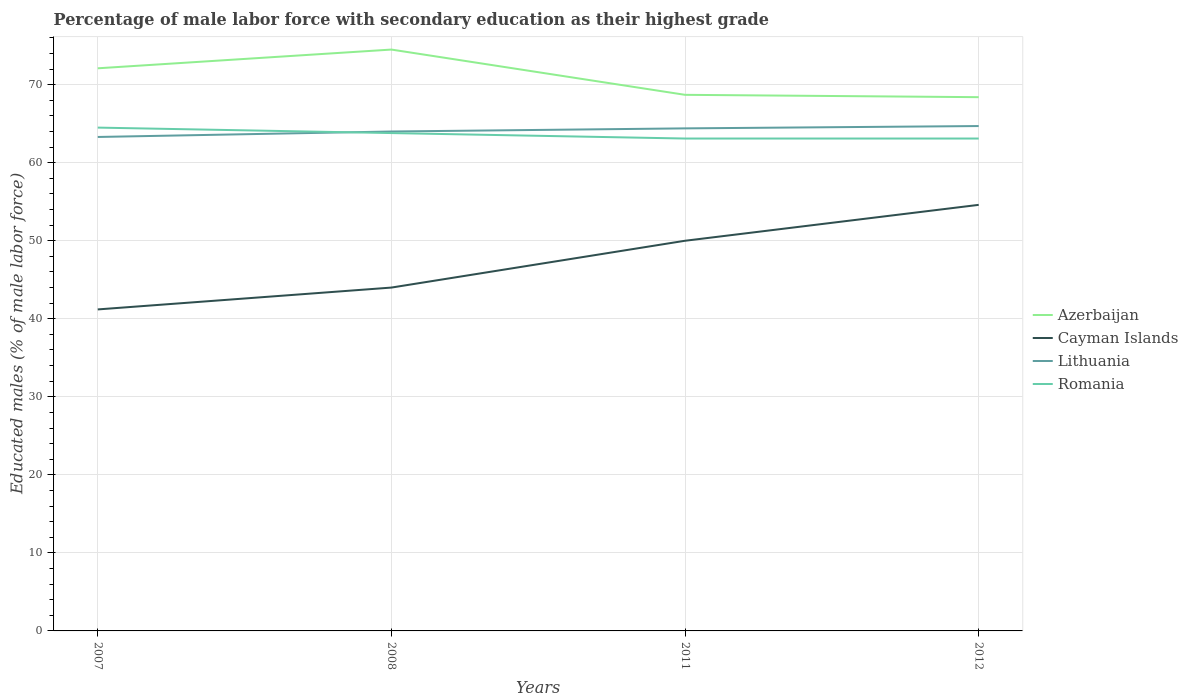How many different coloured lines are there?
Offer a very short reply. 4. Does the line corresponding to Romania intersect with the line corresponding to Azerbaijan?
Your answer should be compact. No. Across all years, what is the maximum percentage of male labor force with secondary education in Lithuania?
Your answer should be compact. 63.3. What is the total percentage of male labor force with secondary education in Lithuania in the graph?
Your response must be concise. -1.1. What is the difference between the highest and the second highest percentage of male labor force with secondary education in Romania?
Your answer should be compact. 1.4. What is the difference between the highest and the lowest percentage of male labor force with secondary education in Lithuania?
Keep it short and to the point. 2. Is the percentage of male labor force with secondary education in Cayman Islands strictly greater than the percentage of male labor force with secondary education in Azerbaijan over the years?
Offer a terse response. Yes. How many years are there in the graph?
Provide a succinct answer. 4. What is the difference between two consecutive major ticks on the Y-axis?
Your response must be concise. 10. Are the values on the major ticks of Y-axis written in scientific E-notation?
Provide a short and direct response. No. Where does the legend appear in the graph?
Offer a very short reply. Center right. How many legend labels are there?
Your response must be concise. 4. How are the legend labels stacked?
Give a very brief answer. Vertical. What is the title of the graph?
Your response must be concise. Percentage of male labor force with secondary education as their highest grade. What is the label or title of the Y-axis?
Keep it short and to the point. Educated males (% of male labor force). What is the Educated males (% of male labor force) of Azerbaijan in 2007?
Ensure brevity in your answer.  72.1. What is the Educated males (% of male labor force) of Cayman Islands in 2007?
Your response must be concise. 41.2. What is the Educated males (% of male labor force) in Lithuania in 2007?
Make the answer very short. 63.3. What is the Educated males (% of male labor force) in Romania in 2007?
Your answer should be very brief. 64.5. What is the Educated males (% of male labor force) in Azerbaijan in 2008?
Provide a succinct answer. 74.5. What is the Educated males (% of male labor force) in Cayman Islands in 2008?
Your answer should be very brief. 44. What is the Educated males (% of male labor force) of Romania in 2008?
Your answer should be compact. 63.8. What is the Educated males (% of male labor force) in Azerbaijan in 2011?
Give a very brief answer. 68.7. What is the Educated males (% of male labor force) of Lithuania in 2011?
Provide a succinct answer. 64.4. What is the Educated males (% of male labor force) of Romania in 2011?
Ensure brevity in your answer.  63.1. What is the Educated males (% of male labor force) of Azerbaijan in 2012?
Ensure brevity in your answer.  68.4. What is the Educated males (% of male labor force) of Cayman Islands in 2012?
Offer a very short reply. 54.6. What is the Educated males (% of male labor force) of Lithuania in 2012?
Make the answer very short. 64.7. What is the Educated males (% of male labor force) in Romania in 2012?
Offer a terse response. 63.1. Across all years, what is the maximum Educated males (% of male labor force) of Azerbaijan?
Your answer should be compact. 74.5. Across all years, what is the maximum Educated males (% of male labor force) in Cayman Islands?
Provide a short and direct response. 54.6. Across all years, what is the maximum Educated males (% of male labor force) in Lithuania?
Keep it short and to the point. 64.7. Across all years, what is the maximum Educated males (% of male labor force) of Romania?
Provide a succinct answer. 64.5. Across all years, what is the minimum Educated males (% of male labor force) in Azerbaijan?
Provide a short and direct response. 68.4. Across all years, what is the minimum Educated males (% of male labor force) of Cayman Islands?
Offer a very short reply. 41.2. Across all years, what is the minimum Educated males (% of male labor force) in Lithuania?
Give a very brief answer. 63.3. Across all years, what is the minimum Educated males (% of male labor force) of Romania?
Ensure brevity in your answer.  63.1. What is the total Educated males (% of male labor force) of Azerbaijan in the graph?
Your answer should be very brief. 283.7. What is the total Educated males (% of male labor force) in Cayman Islands in the graph?
Ensure brevity in your answer.  189.8. What is the total Educated males (% of male labor force) in Lithuania in the graph?
Your answer should be very brief. 256.4. What is the total Educated males (% of male labor force) in Romania in the graph?
Make the answer very short. 254.5. What is the difference between the Educated males (% of male labor force) in Azerbaijan in 2007 and that in 2008?
Ensure brevity in your answer.  -2.4. What is the difference between the Educated males (% of male labor force) of Cayman Islands in 2007 and that in 2008?
Offer a very short reply. -2.8. What is the difference between the Educated males (% of male labor force) in Lithuania in 2007 and that in 2011?
Your answer should be very brief. -1.1. What is the difference between the Educated males (% of male labor force) in Romania in 2007 and that in 2011?
Ensure brevity in your answer.  1.4. What is the difference between the Educated males (% of male labor force) of Romania in 2007 and that in 2012?
Your answer should be compact. 1.4. What is the difference between the Educated males (% of male labor force) in Cayman Islands in 2008 and that in 2011?
Offer a very short reply. -6. What is the difference between the Educated males (% of male labor force) in Lithuania in 2008 and that in 2011?
Offer a very short reply. -0.4. What is the difference between the Educated males (% of male labor force) in Azerbaijan in 2008 and that in 2012?
Your answer should be compact. 6.1. What is the difference between the Educated males (% of male labor force) in Cayman Islands in 2008 and that in 2012?
Ensure brevity in your answer.  -10.6. What is the difference between the Educated males (% of male labor force) in Romania in 2008 and that in 2012?
Provide a short and direct response. 0.7. What is the difference between the Educated males (% of male labor force) in Azerbaijan in 2011 and that in 2012?
Ensure brevity in your answer.  0.3. What is the difference between the Educated males (% of male labor force) in Romania in 2011 and that in 2012?
Offer a terse response. 0. What is the difference between the Educated males (% of male labor force) in Azerbaijan in 2007 and the Educated males (% of male labor force) in Cayman Islands in 2008?
Keep it short and to the point. 28.1. What is the difference between the Educated males (% of male labor force) of Azerbaijan in 2007 and the Educated males (% of male labor force) of Romania in 2008?
Keep it short and to the point. 8.3. What is the difference between the Educated males (% of male labor force) in Cayman Islands in 2007 and the Educated males (% of male labor force) in Lithuania in 2008?
Give a very brief answer. -22.8. What is the difference between the Educated males (% of male labor force) of Cayman Islands in 2007 and the Educated males (% of male labor force) of Romania in 2008?
Your answer should be compact. -22.6. What is the difference between the Educated males (% of male labor force) of Azerbaijan in 2007 and the Educated males (% of male labor force) of Cayman Islands in 2011?
Your response must be concise. 22.1. What is the difference between the Educated males (% of male labor force) of Cayman Islands in 2007 and the Educated males (% of male labor force) of Lithuania in 2011?
Ensure brevity in your answer.  -23.2. What is the difference between the Educated males (% of male labor force) in Cayman Islands in 2007 and the Educated males (% of male labor force) in Romania in 2011?
Provide a succinct answer. -21.9. What is the difference between the Educated males (% of male labor force) in Lithuania in 2007 and the Educated males (% of male labor force) in Romania in 2011?
Your answer should be compact. 0.2. What is the difference between the Educated males (% of male labor force) of Azerbaijan in 2007 and the Educated males (% of male labor force) of Cayman Islands in 2012?
Your answer should be very brief. 17.5. What is the difference between the Educated males (% of male labor force) in Azerbaijan in 2007 and the Educated males (% of male labor force) in Romania in 2012?
Your answer should be compact. 9. What is the difference between the Educated males (% of male labor force) of Cayman Islands in 2007 and the Educated males (% of male labor force) of Lithuania in 2012?
Offer a very short reply. -23.5. What is the difference between the Educated males (% of male labor force) of Cayman Islands in 2007 and the Educated males (% of male labor force) of Romania in 2012?
Your response must be concise. -21.9. What is the difference between the Educated males (% of male labor force) in Azerbaijan in 2008 and the Educated males (% of male labor force) in Cayman Islands in 2011?
Ensure brevity in your answer.  24.5. What is the difference between the Educated males (% of male labor force) of Cayman Islands in 2008 and the Educated males (% of male labor force) of Lithuania in 2011?
Provide a short and direct response. -20.4. What is the difference between the Educated males (% of male labor force) in Cayman Islands in 2008 and the Educated males (% of male labor force) in Romania in 2011?
Provide a succinct answer. -19.1. What is the difference between the Educated males (% of male labor force) in Azerbaijan in 2008 and the Educated males (% of male labor force) in Cayman Islands in 2012?
Provide a short and direct response. 19.9. What is the difference between the Educated males (% of male labor force) in Azerbaijan in 2008 and the Educated males (% of male labor force) in Romania in 2012?
Ensure brevity in your answer.  11.4. What is the difference between the Educated males (% of male labor force) in Cayman Islands in 2008 and the Educated males (% of male labor force) in Lithuania in 2012?
Give a very brief answer. -20.7. What is the difference between the Educated males (% of male labor force) in Cayman Islands in 2008 and the Educated males (% of male labor force) in Romania in 2012?
Give a very brief answer. -19.1. What is the difference between the Educated males (% of male labor force) of Lithuania in 2008 and the Educated males (% of male labor force) of Romania in 2012?
Provide a short and direct response. 0.9. What is the difference between the Educated males (% of male labor force) of Azerbaijan in 2011 and the Educated males (% of male labor force) of Lithuania in 2012?
Ensure brevity in your answer.  4. What is the difference between the Educated males (% of male labor force) of Azerbaijan in 2011 and the Educated males (% of male labor force) of Romania in 2012?
Ensure brevity in your answer.  5.6. What is the difference between the Educated males (% of male labor force) of Cayman Islands in 2011 and the Educated males (% of male labor force) of Lithuania in 2012?
Offer a very short reply. -14.7. What is the difference between the Educated males (% of male labor force) in Cayman Islands in 2011 and the Educated males (% of male labor force) in Romania in 2012?
Your response must be concise. -13.1. What is the average Educated males (% of male labor force) in Azerbaijan per year?
Your answer should be compact. 70.92. What is the average Educated males (% of male labor force) of Cayman Islands per year?
Make the answer very short. 47.45. What is the average Educated males (% of male labor force) of Lithuania per year?
Your answer should be compact. 64.1. What is the average Educated males (% of male labor force) of Romania per year?
Provide a succinct answer. 63.62. In the year 2007, what is the difference between the Educated males (% of male labor force) in Azerbaijan and Educated males (% of male labor force) in Cayman Islands?
Provide a succinct answer. 30.9. In the year 2007, what is the difference between the Educated males (% of male labor force) of Azerbaijan and Educated males (% of male labor force) of Romania?
Provide a short and direct response. 7.6. In the year 2007, what is the difference between the Educated males (% of male labor force) of Cayman Islands and Educated males (% of male labor force) of Lithuania?
Offer a very short reply. -22.1. In the year 2007, what is the difference between the Educated males (% of male labor force) of Cayman Islands and Educated males (% of male labor force) of Romania?
Offer a terse response. -23.3. In the year 2007, what is the difference between the Educated males (% of male labor force) in Lithuania and Educated males (% of male labor force) in Romania?
Offer a very short reply. -1.2. In the year 2008, what is the difference between the Educated males (% of male labor force) of Azerbaijan and Educated males (% of male labor force) of Cayman Islands?
Keep it short and to the point. 30.5. In the year 2008, what is the difference between the Educated males (% of male labor force) of Azerbaijan and Educated males (% of male labor force) of Lithuania?
Your response must be concise. 10.5. In the year 2008, what is the difference between the Educated males (% of male labor force) in Cayman Islands and Educated males (% of male labor force) in Romania?
Make the answer very short. -19.8. In the year 2011, what is the difference between the Educated males (% of male labor force) of Azerbaijan and Educated males (% of male labor force) of Lithuania?
Offer a very short reply. 4.3. In the year 2011, what is the difference between the Educated males (% of male labor force) of Azerbaijan and Educated males (% of male labor force) of Romania?
Keep it short and to the point. 5.6. In the year 2011, what is the difference between the Educated males (% of male labor force) in Cayman Islands and Educated males (% of male labor force) in Lithuania?
Offer a terse response. -14.4. In the year 2011, what is the difference between the Educated males (% of male labor force) in Cayman Islands and Educated males (% of male labor force) in Romania?
Offer a very short reply. -13.1. In the year 2011, what is the difference between the Educated males (% of male labor force) in Lithuania and Educated males (% of male labor force) in Romania?
Your response must be concise. 1.3. In the year 2012, what is the difference between the Educated males (% of male labor force) of Azerbaijan and Educated males (% of male labor force) of Cayman Islands?
Offer a very short reply. 13.8. In the year 2012, what is the difference between the Educated males (% of male labor force) of Cayman Islands and Educated males (% of male labor force) of Lithuania?
Ensure brevity in your answer.  -10.1. In the year 2012, what is the difference between the Educated males (% of male labor force) in Lithuania and Educated males (% of male labor force) in Romania?
Offer a terse response. 1.6. What is the ratio of the Educated males (% of male labor force) in Azerbaijan in 2007 to that in 2008?
Your answer should be compact. 0.97. What is the ratio of the Educated males (% of male labor force) in Cayman Islands in 2007 to that in 2008?
Make the answer very short. 0.94. What is the ratio of the Educated males (% of male labor force) of Lithuania in 2007 to that in 2008?
Your response must be concise. 0.99. What is the ratio of the Educated males (% of male labor force) in Romania in 2007 to that in 2008?
Offer a very short reply. 1.01. What is the ratio of the Educated males (% of male labor force) in Azerbaijan in 2007 to that in 2011?
Ensure brevity in your answer.  1.05. What is the ratio of the Educated males (% of male labor force) in Cayman Islands in 2007 to that in 2011?
Offer a terse response. 0.82. What is the ratio of the Educated males (% of male labor force) of Lithuania in 2007 to that in 2011?
Your response must be concise. 0.98. What is the ratio of the Educated males (% of male labor force) in Romania in 2007 to that in 2011?
Provide a succinct answer. 1.02. What is the ratio of the Educated males (% of male labor force) of Azerbaijan in 2007 to that in 2012?
Ensure brevity in your answer.  1.05. What is the ratio of the Educated males (% of male labor force) in Cayman Islands in 2007 to that in 2012?
Ensure brevity in your answer.  0.75. What is the ratio of the Educated males (% of male labor force) in Lithuania in 2007 to that in 2012?
Offer a very short reply. 0.98. What is the ratio of the Educated males (% of male labor force) of Romania in 2007 to that in 2012?
Provide a succinct answer. 1.02. What is the ratio of the Educated males (% of male labor force) in Azerbaijan in 2008 to that in 2011?
Your response must be concise. 1.08. What is the ratio of the Educated males (% of male labor force) in Romania in 2008 to that in 2011?
Ensure brevity in your answer.  1.01. What is the ratio of the Educated males (% of male labor force) in Azerbaijan in 2008 to that in 2012?
Ensure brevity in your answer.  1.09. What is the ratio of the Educated males (% of male labor force) of Cayman Islands in 2008 to that in 2012?
Give a very brief answer. 0.81. What is the ratio of the Educated males (% of male labor force) of Romania in 2008 to that in 2012?
Provide a short and direct response. 1.01. What is the ratio of the Educated males (% of male labor force) in Azerbaijan in 2011 to that in 2012?
Make the answer very short. 1. What is the ratio of the Educated males (% of male labor force) in Cayman Islands in 2011 to that in 2012?
Provide a succinct answer. 0.92. What is the ratio of the Educated males (% of male labor force) in Romania in 2011 to that in 2012?
Offer a very short reply. 1. What is the difference between the highest and the second highest Educated males (% of male labor force) in Azerbaijan?
Your response must be concise. 2.4. What is the difference between the highest and the lowest Educated males (% of male labor force) in Lithuania?
Make the answer very short. 1.4. What is the difference between the highest and the lowest Educated males (% of male labor force) of Romania?
Make the answer very short. 1.4. 